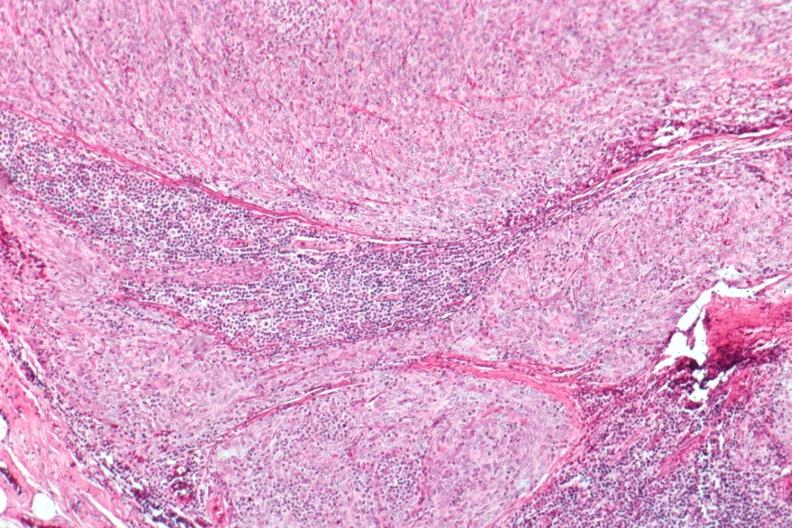does this image show epithelial predominant?
Answer the question using a single word or phrase. Yes 